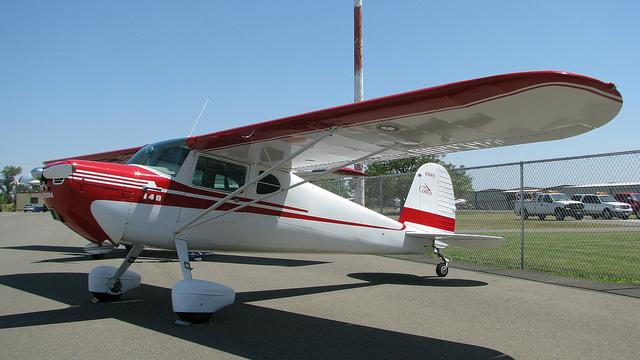How many wheels are used on the bottom of this aircraft?

Choices:
A) eight
B) twelve
C) three
D) six three 